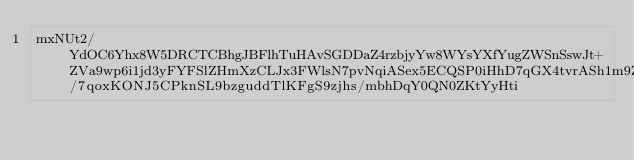Convert code to text. <code><loc_0><loc_0><loc_500><loc_500><_SML_>mxNUt2/YdOC6Yhx8W5DRCTCBhgJBFlhTuHAvSGDDaZ4rzbjyYw8WYsYXfYugZWSnSswJt+ZVa9wp6i1jd3yFYFSlZHmXzCLJx3FWlsN7pvNqiASex5ECQSP0iHhD7qGX4tvrASh1m9ZFx38KXoXWHVZ/7qoxKONJ5CPknSL9bzguddTlKFgS9zjhs/mbhDqY0QN0ZKtYyHti</code> 